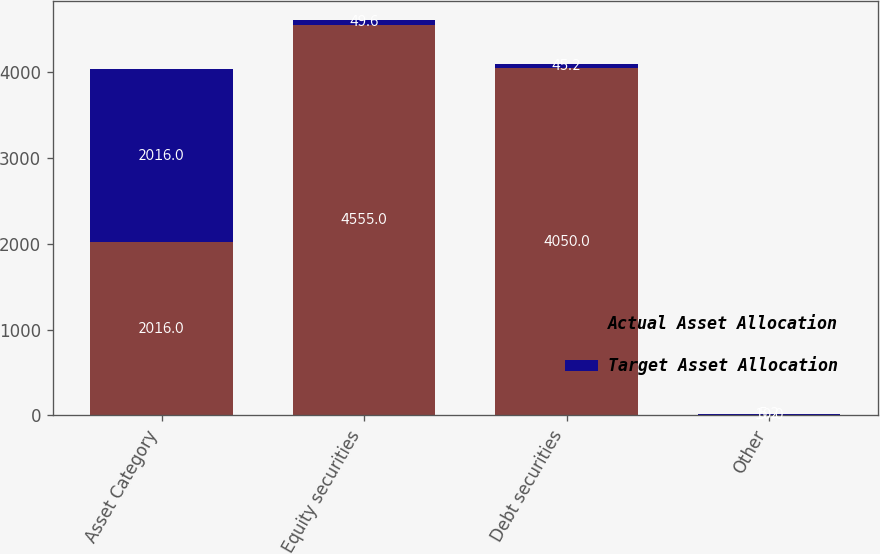Convert chart to OTSL. <chart><loc_0><loc_0><loc_500><loc_500><stacked_bar_chart><ecel><fcel>Asset Category<fcel>Equity securities<fcel>Debt securities<fcel>Other<nl><fcel>Actual Asset Allocation<fcel>2016<fcel>4555<fcel>4050<fcel>10<nl><fcel>Target Asset Allocation<fcel>2016<fcel>49.6<fcel>45.2<fcel>5.2<nl></chart> 